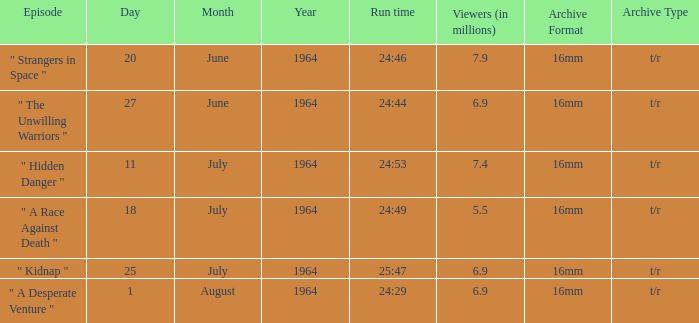How many viewers were there on 1august1964? 6.9. 